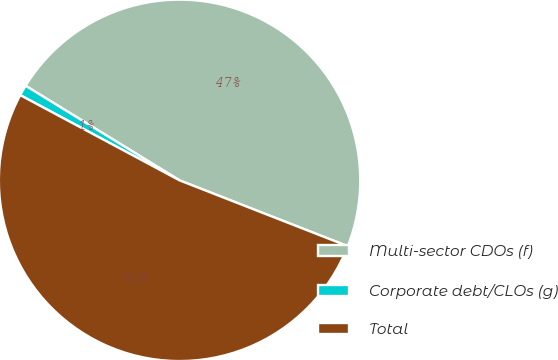Convert chart to OTSL. <chart><loc_0><loc_0><loc_500><loc_500><pie_chart><fcel>Multi-sector CDOs (f)<fcel>Corporate debt/CLOs (g)<fcel>Total<nl><fcel>47.17%<fcel>0.95%<fcel>51.88%<nl></chart> 